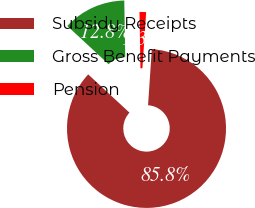Convert chart to OTSL. <chart><loc_0><loc_0><loc_500><loc_500><pie_chart><fcel>Subsidy Receipts<fcel>Gross Benefit Payments<fcel>Pension<nl><fcel>85.82%<fcel>12.83%<fcel>1.34%<nl></chart> 